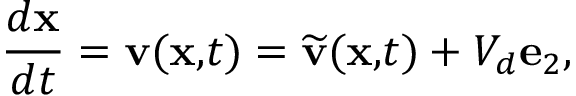Convert formula to latex. <formula><loc_0><loc_0><loc_500><loc_500>\frac { d x } { d t } = v ( x , t ) = \widetilde { v } ( x , t ) + V _ { d } e _ { 2 } , \ \</formula> 